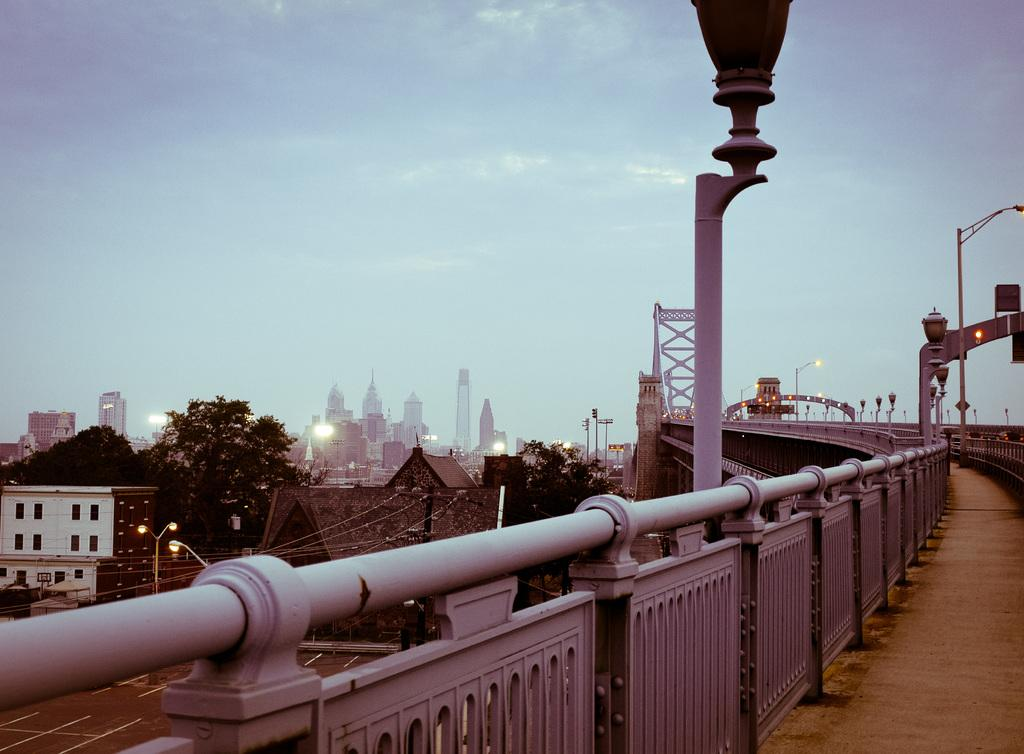What type of structures can be seen in the image? There are many buildings in the image. Are there any natural elements present in the image? Yes, there are few trees in the image. What can be seen illuminating the image? There are many lights in the image. What type of man-made structure is present in the image? There is a bridge in the image. What is visible in the background of the image? The sky is visible in the image. What type of creature is causing destruction and flames in the image? There is no creature, destruction, or flames present in the image. The image features many buildings, few trees, many lights, a bridge, and the sky. 